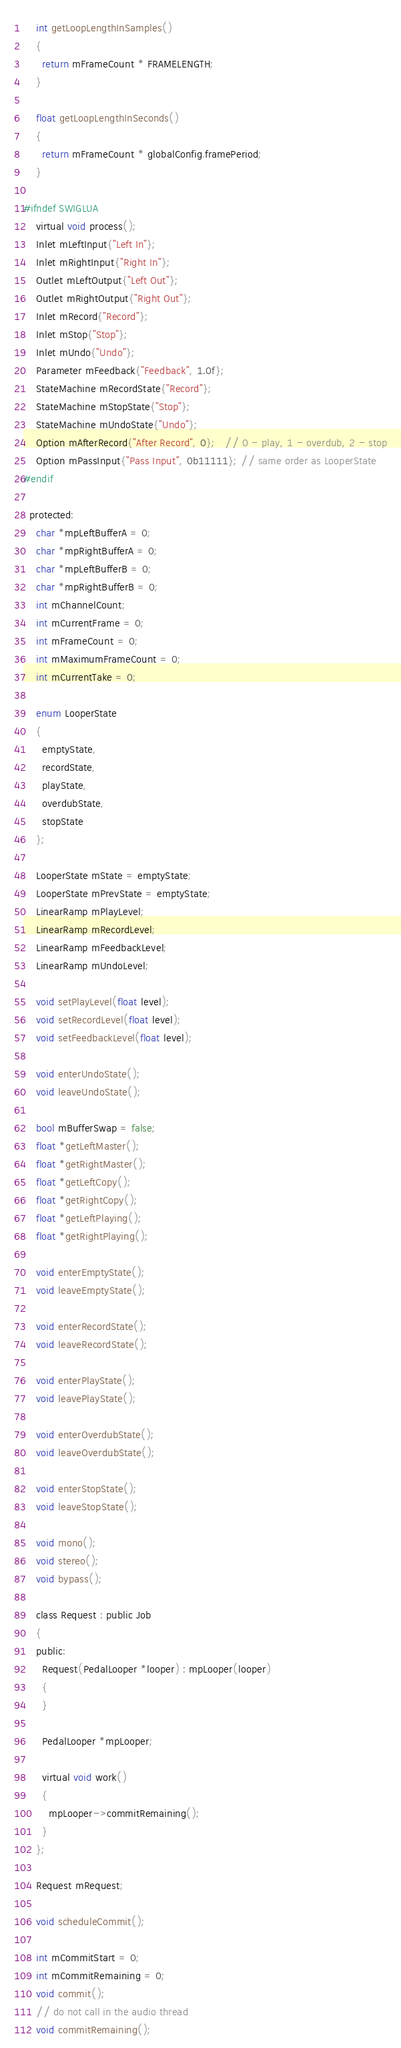Convert code to text. <code><loc_0><loc_0><loc_500><loc_500><_C_>    int getLoopLengthInSamples()
    {
      return mFrameCount * FRAMELENGTH;
    }

    float getLoopLengthInSeconds()
    {
      return mFrameCount * globalConfig.framePeriod;
    }

#ifndef SWIGLUA
    virtual void process();
    Inlet mLeftInput{"Left In"};
    Inlet mRightInput{"Right In"};
    Outlet mLeftOutput{"Left Out"};
    Outlet mRightOutput{"Right Out"};
    Inlet mRecord{"Record"};
    Inlet mStop{"Stop"};
    Inlet mUndo{"Undo"};
    Parameter mFeedback{"Feedback", 1.0f};
    StateMachine mRecordState{"Record"};
    StateMachine mStopState{"Stop"};
    StateMachine mUndoState{"Undo"};
    Option mAfterRecord{"After Record", 0};   // 0 - play, 1 - overdub, 2 - stop
    Option mPassInput{"Pass Input", 0b11111}; // same order as LooperState
#endif

  protected:
    char *mpLeftBufferA = 0;
    char *mpRightBufferA = 0;
    char *mpLeftBufferB = 0;
    char *mpRightBufferB = 0;
    int mChannelCount;
    int mCurrentFrame = 0;
    int mFrameCount = 0;
    int mMaximumFrameCount = 0;
    int mCurrentTake = 0;

    enum LooperState
    {
      emptyState,
      recordState,
      playState,
      overdubState,
      stopState
    };

    LooperState mState = emptyState;
    LooperState mPrevState = emptyState;
    LinearRamp mPlayLevel;
    LinearRamp mRecordLevel;
    LinearRamp mFeedbackLevel;
    LinearRamp mUndoLevel;

    void setPlayLevel(float level);
    void setRecordLevel(float level);
    void setFeedbackLevel(float level);

    void enterUndoState();
    void leaveUndoState();

    bool mBufferSwap = false;
    float *getLeftMaster();
    float *getRightMaster();
    float *getLeftCopy();
    float *getRightCopy();
    float *getLeftPlaying();
    float *getRightPlaying();

    void enterEmptyState();
    void leaveEmptyState();

    void enterRecordState();
    void leaveRecordState();

    void enterPlayState();
    void leavePlayState();

    void enterOverdubState();
    void leaveOverdubState();

    void enterStopState();
    void leaveStopState();

    void mono();
    void stereo();
    void bypass();

    class Request : public Job
    {
    public:
      Request(PedalLooper *looper) : mpLooper(looper)
      {
      }

      PedalLooper *mpLooper;

      virtual void work()
      {
        mpLooper->commitRemaining();
      }
    };

    Request mRequest;

    void scheduleCommit();

    int mCommitStart = 0;
    int mCommitRemaining = 0;
    void commit();
    // do not call in the audio thread
    void commitRemaining();
</code> 